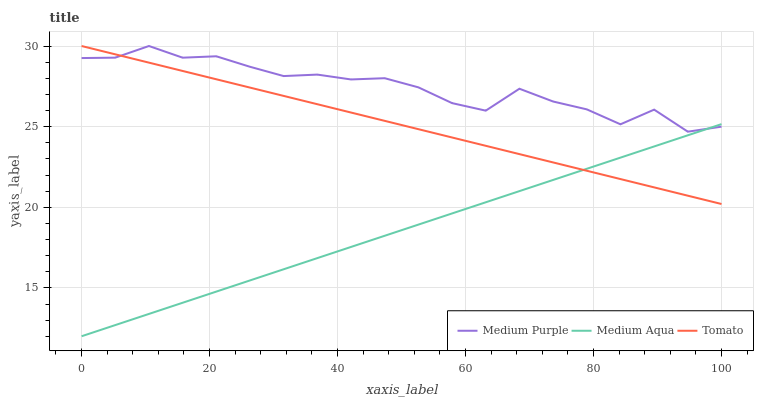Does Tomato have the minimum area under the curve?
Answer yes or no. No. Does Tomato have the maximum area under the curve?
Answer yes or no. No. Is Tomato the smoothest?
Answer yes or no. No. Is Tomato the roughest?
Answer yes or no. No. Does Tomato have the lowest value?
Answer yes or no. No. Does Medium Aqua have the highest value?
Answer yes or no. No. 